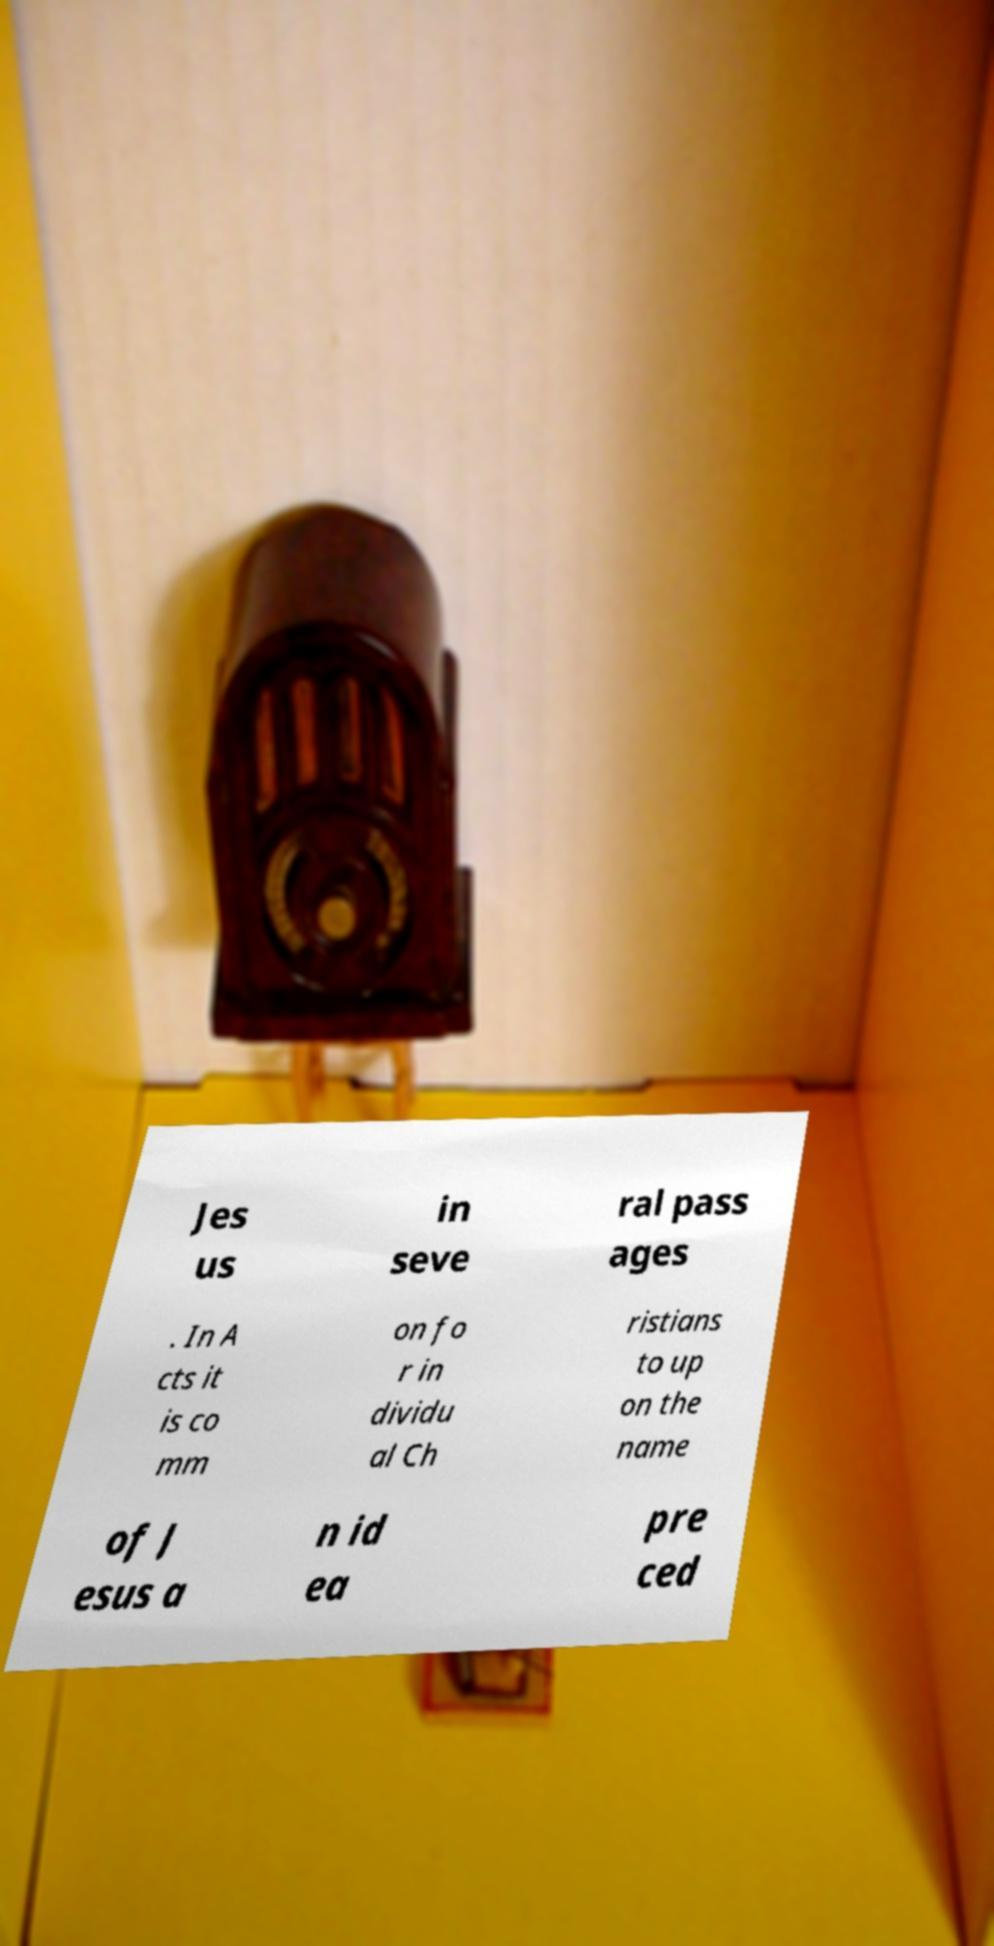What messages or text are displayed in this image? I need them in a readable, typed format. Jes us in seve ral pass ages . In A cts it is co mm on fo r in dividu al Ch ristians to up on the name of J esus a n id ea pre ced 